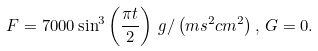Convert formula to latex. <formula><loc_0><loc_0><loc_500><loc_500>F = 7 0 0 0 \sin ^ { 3 } \left ( \frac { \pi t } { 2 } \right ) \, g / \left ( m s ^ { 2 } c m ^ { 2 } \right ) , \, G = 0 .</formula> 